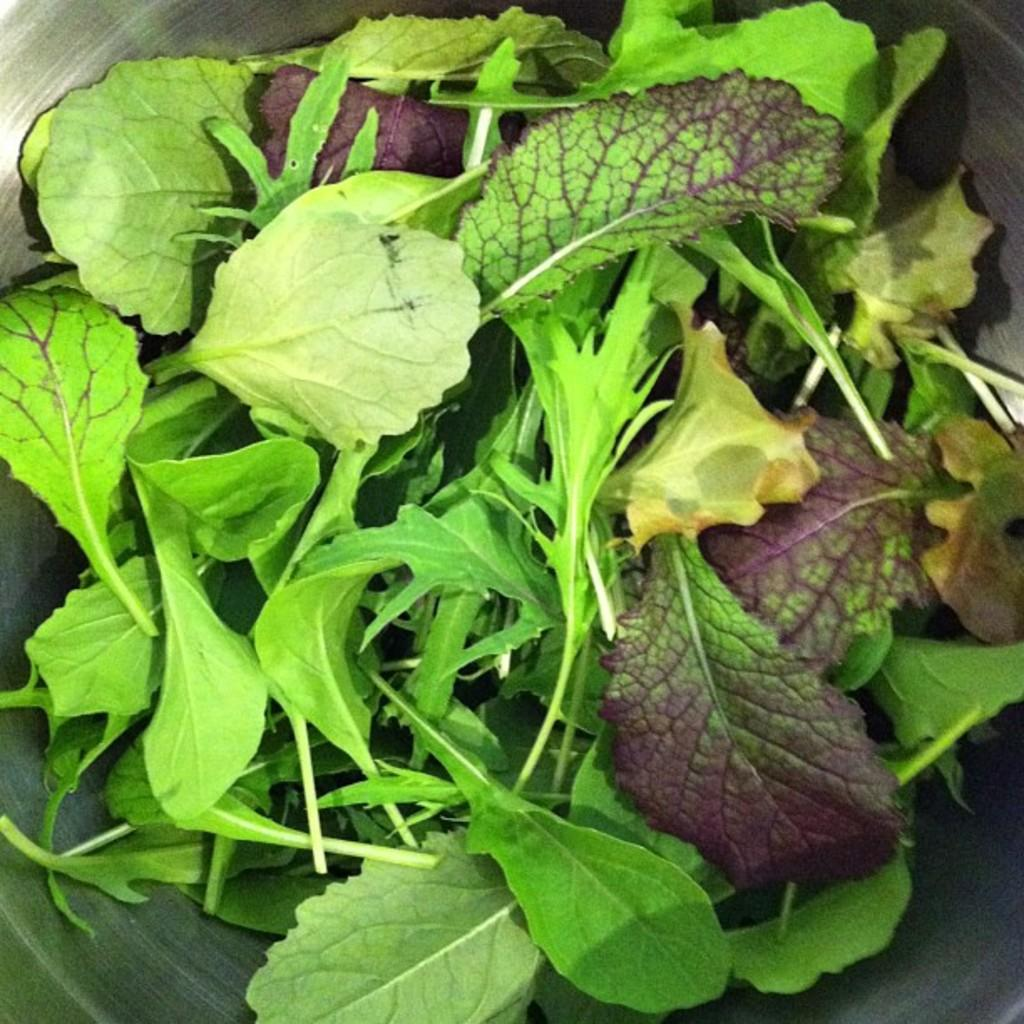What is located in the center of the image? There is a bowl in the center of the image. What is inside the bowl? The bowl contains green leafy vegetables. Where is the faucet located in the image? There is no faucet present in the image. Can you describe the swimming technique used by the vegetables in the image? The vegetables are not swimming in the image; they are stationary in the bowl. 